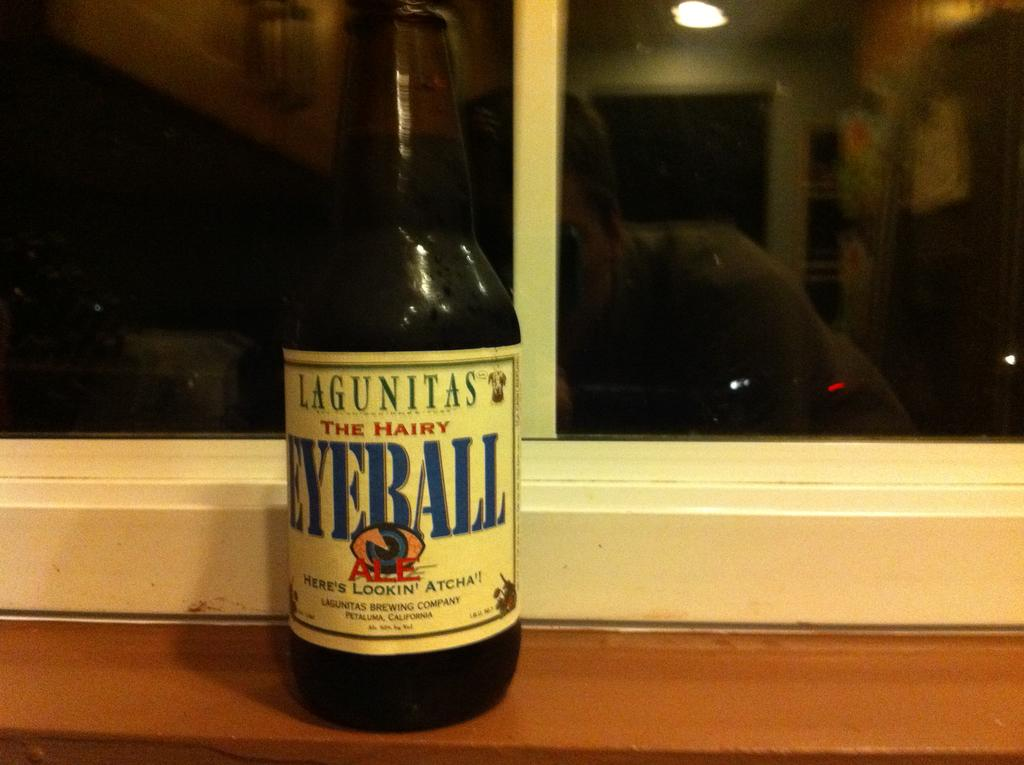<image>
Provide a brief description of the given image. The beer shown has the unusual name the hairy eyeball. 